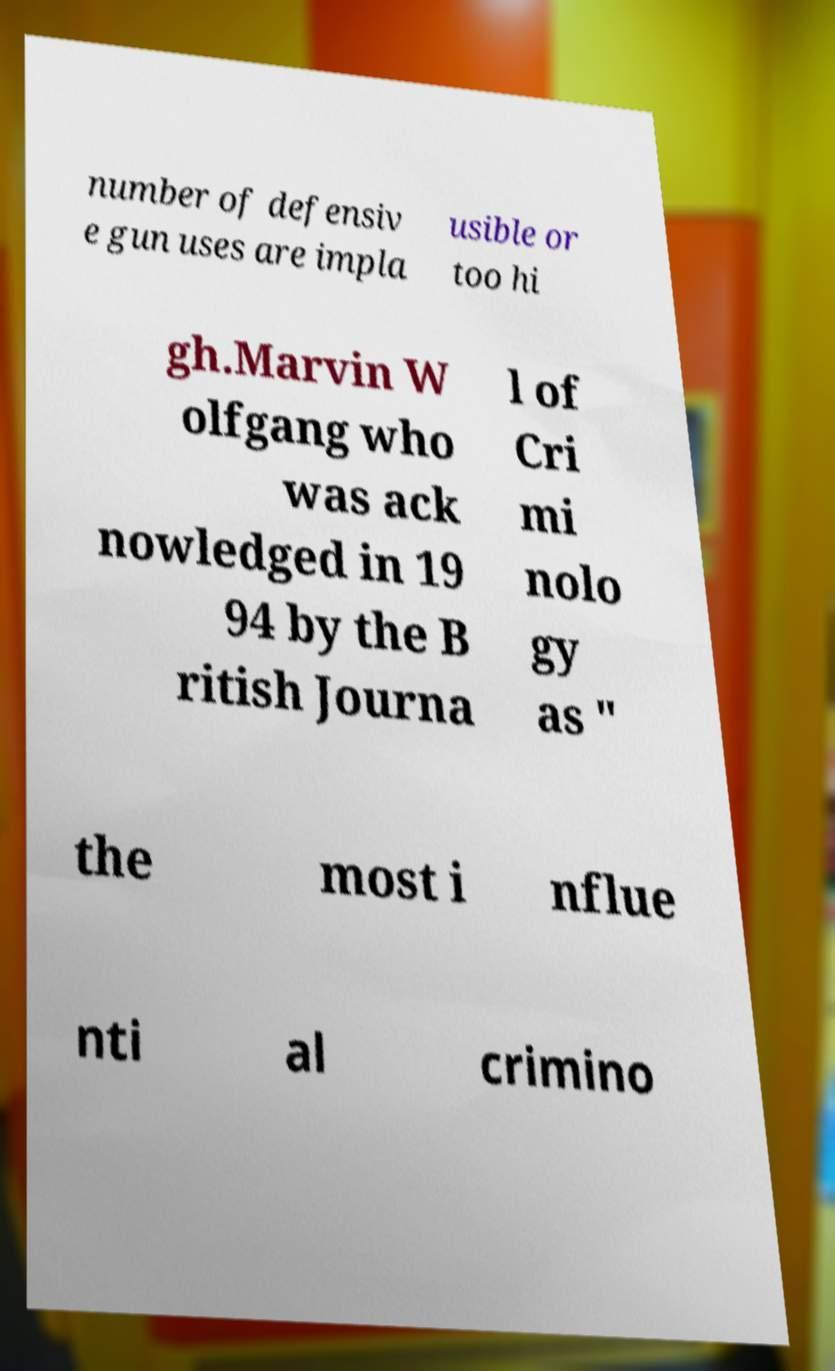I need the written content from this picture converted into text. Can you do that? number of defensiv e gun uses are impla usible or too hi gh.Marvin W olfgang who was ack nowledged in 19 94 by the B ritish Journa l of Cri mi nolo gy as ″ the most i nflue nti al crimino 